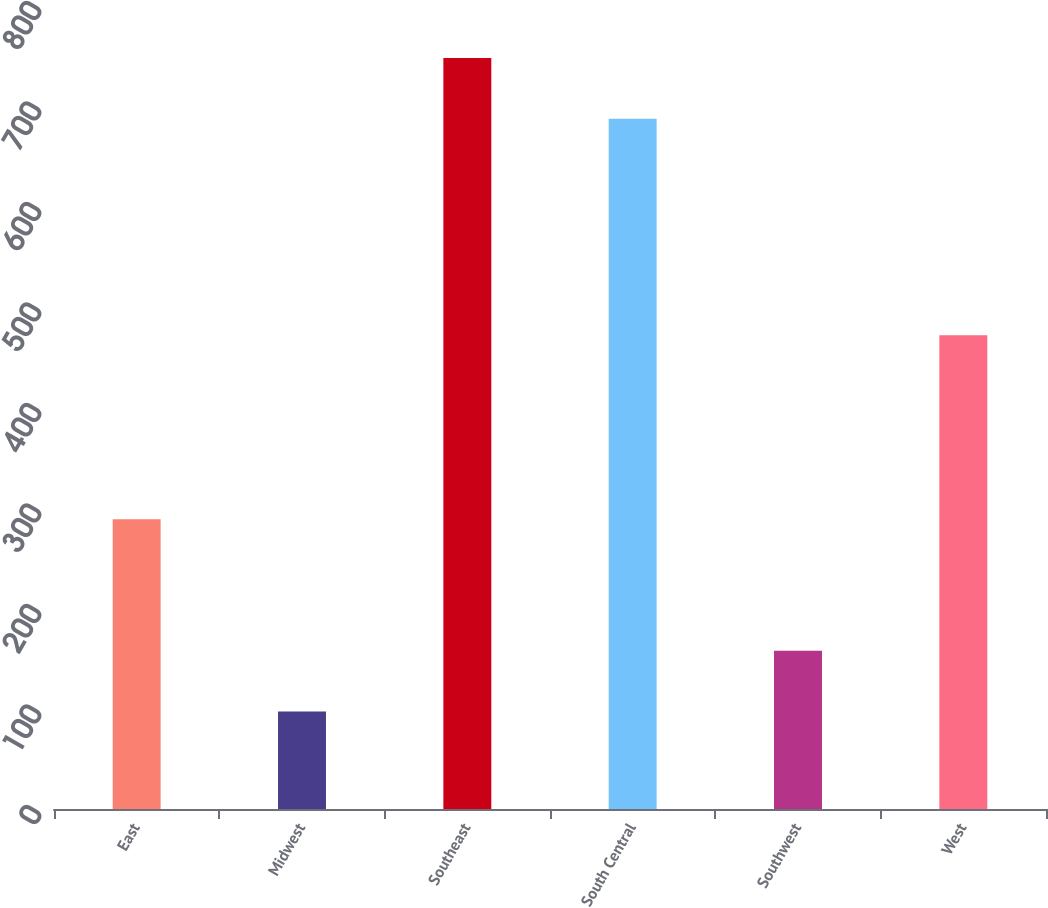Convert chart. <chart><loc_0><loc_0><loc_500><loc_500><bar_chart><fcel>East<fcel>Midwest<fcel>Southeast<fcel>South Central<fcel>Southwest<fcel>West<nl><fcel>288.2<fcel>97<fcel>747.22<fcel>686.8<fcel>157.42<fcel>471.5<nl></chart> 